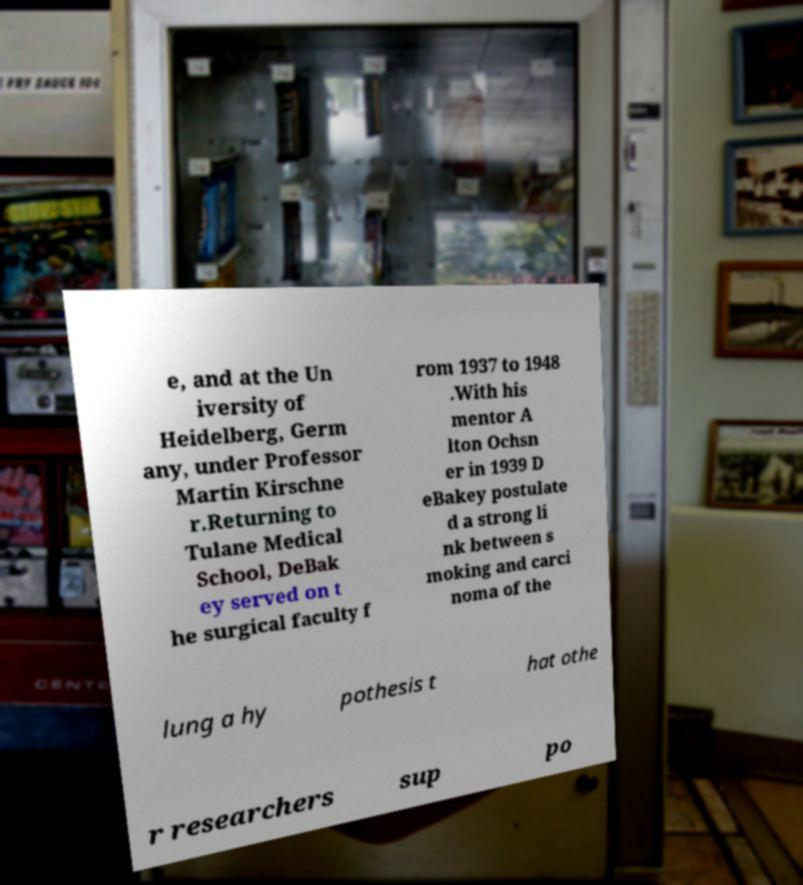Can you accurately transcribe the text from the provided image for me? e, and at the Un iversity of Heidelberg, Germ any, under Professor Martin Kirschne r.Returning to Tulane Medical School, DeBak ey served on t he surgical faculty f rom 1937 to 1948 .With his mentor A lton Ochsn er in 1939 D eBakey postulate d a strong li nk between s moking and carci noma of the lung a hy pothesis t hat othe r researchers sup po 